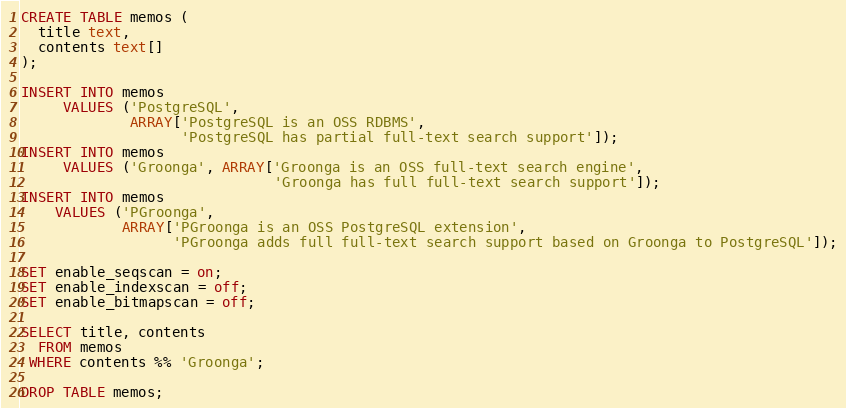<code> <loc_0><loc_0><loc_500><loc_500><_SQL_>CREATE TABLE memos (
  title text,
  contents text[]
);

INSERT INTO memos
     VALUES ('PostgreSQL',
             ARRAY['PostgreSQL is an OSS RDBMS',
                   'PostgreSQL has partial full-text search support']);
INSERT INTO memos
     VALUES ('Groonga', ARRAY['Groonga is an OSS full-text search engine',
                              'Groonga has full full-text search support']);
INSERT INTO memos
    VALUES ('PGroonga',
            ARRAY['PGroonga is an OSS PostgreSQL extension',
                  'PGroonga adds full full-text search support based on Groonga to PostgreSQL']);

SET enable_seqscan = on;
SET enable_indexscan = off;
SET enable_bitmapscan = off;

SELECT title, contents
  FROM memos
 WHERE contents %% 'Groonga';

DROP TABLE memos;
</code> 